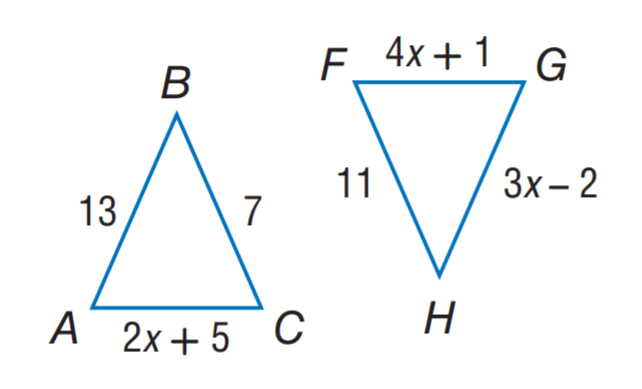Answer the mathemtical geometry problem and directly provide the correct option letter.
Question: \triangle A B C \cong \triangle F G H. Find x.
Choices: A: 2 B: 3 C: 7 D: 13 B 